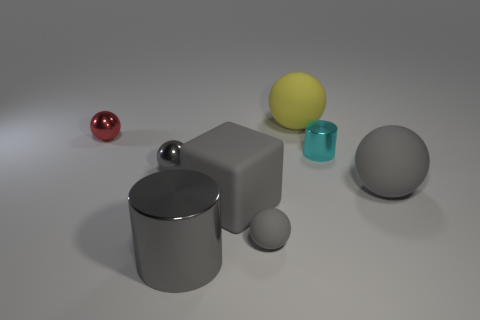Are there any other red objects of the same shape as the red shiny thing?
Your response must be concise. No. What shape is the large object that is behind the red ball that is behind the cyan metal cylinder?
Provide a short and direct response. Sphere. There is a gray thing that is left of the gray metallic cylinder; what shape is it?
Ensure brevity in your answer.  Sphere. Does the large rubber object that is behind the red sphere have the same color as the large rubber sphere on the right side of the large yellow matte ball?
Provide a short and direct response. No. How many balls are both behind the tiny cyan shiny object and left of the big cube?
Your answer should be very brief. 1. There is a red object that is made of the same material as the gray cylinder; what is its size?
Make the answer very short. Small. The red metallic thing has what size?
Give a very brief answer. Small. What is the tiny cyan cylinder made of?
Provide a short and direct response. Metal. There is a cyan cylinder that is in front of the yellow object; is it the same size as the yellow ball?
Make the answer very short. No. What number of objects are either matte blocks or gray metallic cylinders?
Make the answer very short. 2. 